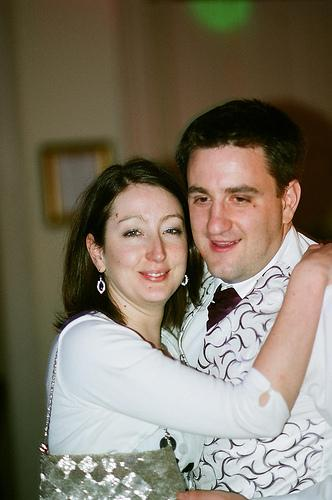Briefly state the primary interaction between the two people in the image. A man and woman are hugging each other with smiles on their faces. What are the predominant colors and patterns seen on the man and the woman's attire? Predominant colors are white and maroon, with a patterned design on the man's vest. What is the key interaction between the man and woman in this image, and what do their faces reveal about their emotions? They are hugging each other and seem to be happy, as both have smiles on their faces. Provide an overview of the woman's overall appearance in the image, focusing on her hairstyle and accessories. The woman has brown shoulder-length hair, is wearing diamond hoop earrings, and carries a silver sequined purse on her shoulder. Create a concise description of the clothing and accessories worn by both individuals in the image. The man wears a white shirt, maroon tie, and black-and-white vest. The woman has on a white blouse, earrings, and a silver sequined purse. In one sentence, describe how the man and woman in the image appear to be feeling. Both the man and woman seem to be happy and smiling as they embrace each other. How are the man and woman connected to each other in this image? The woman has her hand on the man's shoulder, and they are hugging each other. Identify the clothing elements and accessories present in the image for each person. Man: white shirt, maroon tie, patterned vest. Woman: white blouse, diamond hoop earrings, silver sequined purse. List the most noticeable features of both individuals in the image. Man: short brown hair, white shirt, vest, tie. Woman: brown shoulder-length hair, white blouse, silver purse, earrings. 